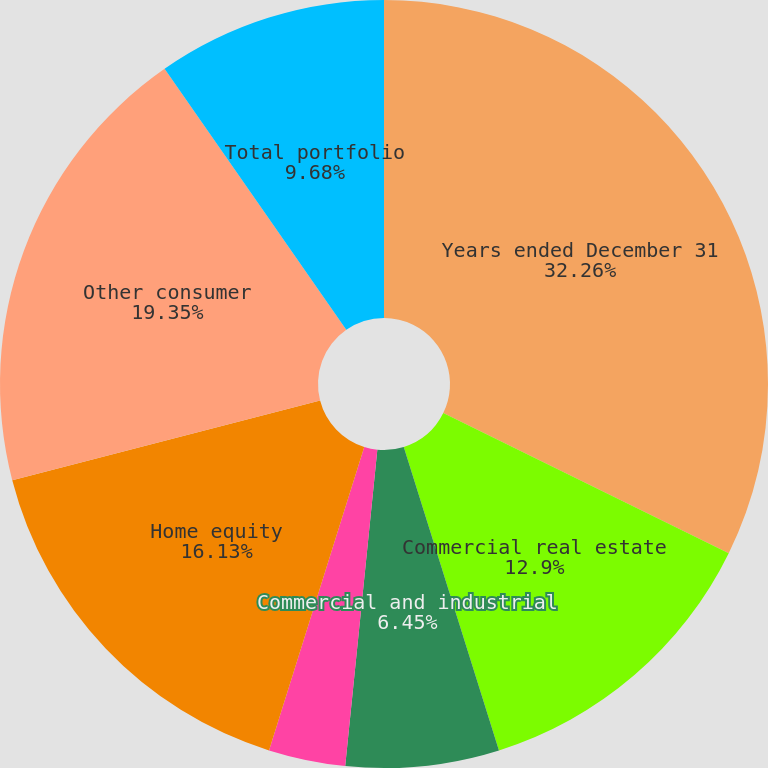<chart> <loc_0><loc_0><loc_500><loc_500><pie_chart><fcel>Years ended December 31<fcel>Commercial real estate<fcel>Commercial and industrial<fcel>Equipment financing<fcel>Residential mortgage<fcel>Home equity<fcel>Other consumer<fcel>Total portfolio<nl><fcel>32.26%<fcel>12.9%<fcel>6.45%<fcel>0.0%<fcel>3.23%<fcel>16.13%<fcel>19.35%<fcel>9.68%<nl></chart> 